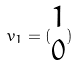Convert formula to latex. <formula><loc_0><loc_0><loc_500><loc_500>v _ { 1 } = ( \begin{matrix} 1 \\ 0 \end{matrix} )</formula> 